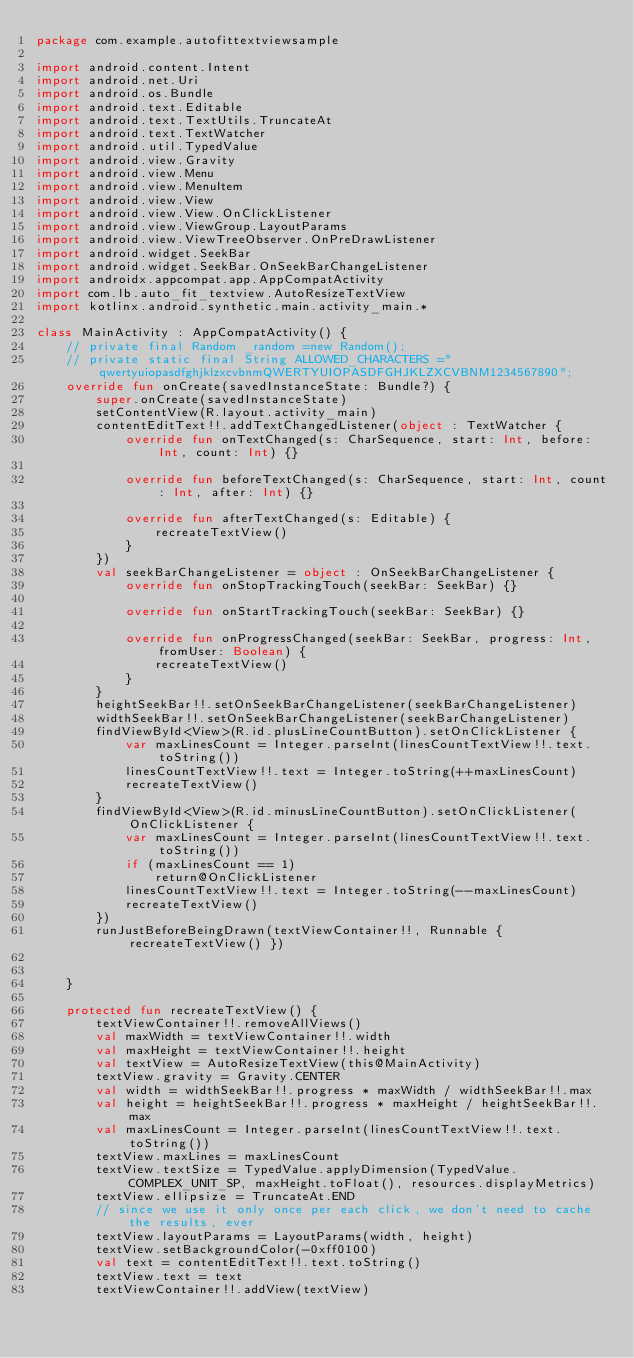<code> <loc_0><loc_0><loc_500><loc_500><_Kotlin_>package com.example.autofittextviewsample

import android.content.Intent
import android.net.Uri
import android.os.Bundle
import android.text.Editable
import android.text.TextUtils.TruncateAt
import android.text.TextWatcher
import android.util.TypedValue
import android.view.Gravity
import android.view.Menu
import android.view.MenuItem
import android.view.View
import android.view.View.OnClickListener
import android.view.ViewGroup.LayoutParams
import android.view.ViewTreeObserver.OnPreDrawListener
import android.widget.SeekBar
import android.widget.SeekBar.OnSeekBarChangeListener
import androidx.appcompat.app.AppCompatActivity
import com.lb.auto_fit_textview.AutoResizeTextView
import kotlinx.android.synthetic.main.activity_main.*

class MainActivity : AppCompatActivity() {
    // private final Random _random =new Random();
    // private static final String ALLOWED_CHARACTERS ="qwertyuiopasdfghjklzxcvbnmQWERTYUIOPASDFGHJKLZXCVBNM1234567890";
    override fun onCreate(savedInstanceState: Bundle?) {
        super.onCreate(savedInstanceState)
        setContentView(R.layout.activity_main)
        contentEditText!!.addTextChangedListener(object : TextWatcher {
            override fun onTextChanged(s: CharSequence, start: Int, before: Int, count: Int) {}

            override fun beforeTextChanged(s: CharSequence, start: Int, count: Int, after: Int) {}

            override fun afterTextChanged(s: Editable) {
                recreateTextView()
            }
        })
        val seekBarChangeListener = object : OnSeekBarChangeListener {
            override fun onStopTrackingTouch(seekBar: SeekBar) {}

            override fun onStartTrackingTouch(seekBar: SeekBar) {}

            override fun onProgressChanged(seekBar: SeekBar, progress: Int, fromUser: Boolean) {
                recreateTextView()
            }
        }
        heightSeekBar!!.setOnSeekBarChangeListener(seekBarChangeListener)
        widthSeekBar!!.setOnSeekBarChangeListener(seekBarChangeListener)
        findViewById<View>(R.id.plusLineCountButton).setOnClickListener {
            var maxLinesCount = Integer.parseInt(linesCountTextView!!.text.toString())
            linesCountTextView!!.text = Integer.toString(++maxLinesCount)
            recreateTextView()
        }
        findViewById<View>(R.id.minusLineCountButton).setOnClickListener(OnClickListener {
            var maxLinesCount = Integer.parseInt(linesCountTextView!!.text.toString())
            if (maxLinesCount == 1)
                return@OnClickListener
            linesCountTextView!!.text = Integer.toString(--maxLinesCount)
            recreateTextView()
        })
        runJustBeforeBeingDrawn(textViewContainer!!, Runnable { recreateTextView() })


    }

    protected fun recreateTextView() {
        textViewContainer!!.removeAllViews()
        val maxWidth = textViewContainer!!.width
        val maxHeight = textViewContainer!!.height
        val textView = AutoResizeTextView(this@MainActivity)
        textView.gravity = Gravity.CENTER
        val width = widthSeekBar!!.progress * maxWidth / widthSeekBar!!.max
        val height = heightSeekBar!!.progress * maxHeight / heightSeekBar!!.max
        val maxLinesCount = Integer.parseInt(linesCountTextView!!.text.toString())
        textView.maxLines = maxLinesCount
        textView.textSize = TypedValue.applyDimension(TypedValue.COMPLEX_UNIT_SP, maxHeight.toFloat(), resources.displayMetrics)
        textView.ellipsize = TruncateAt.END
        // since we use it only once per each click, we don't need to cache the results, ever
        textView.layoutParams = LayoutParams(width, height)
        textView.setBackgroundColor(-0xff0100)
        val text = contentEditText!!.text.toString()
        textView.text = text
        textViewContainer!!.addView(textView)</code> 